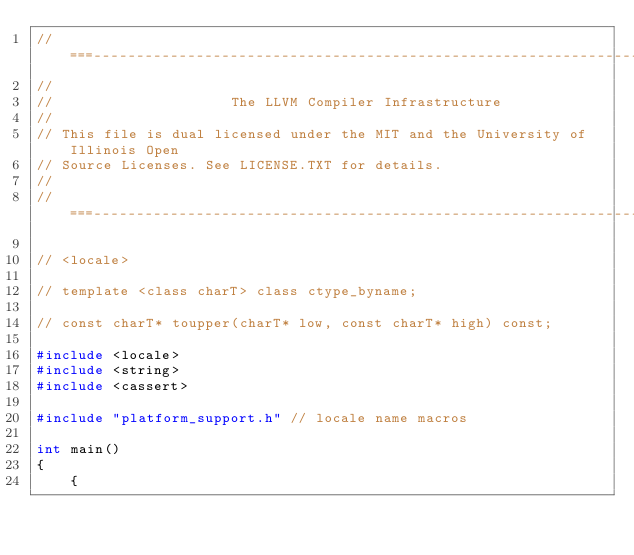Convert code to text. <code><loc_0><loc_0><loc_500><loc_500><_C++_>//===----------------------------------------------------------------------===//
//
//                     The LLVM Compiler Infrastructure
//
// This file is dual licensed under the MIT and the University of Illinois Open
// Source Licenses. See LICENSE.TXT for details.
//
//===----------------------------------------------------------------------===//

// <locale>

// template <class charT> class ctype_byname;

// const charT* toupper(charT* low, const charT* high) const;

#include <locale>
#include <string>
#include <cassert>

#include "platform_support.h" // locale name macros

int main()
{
    {</code> 